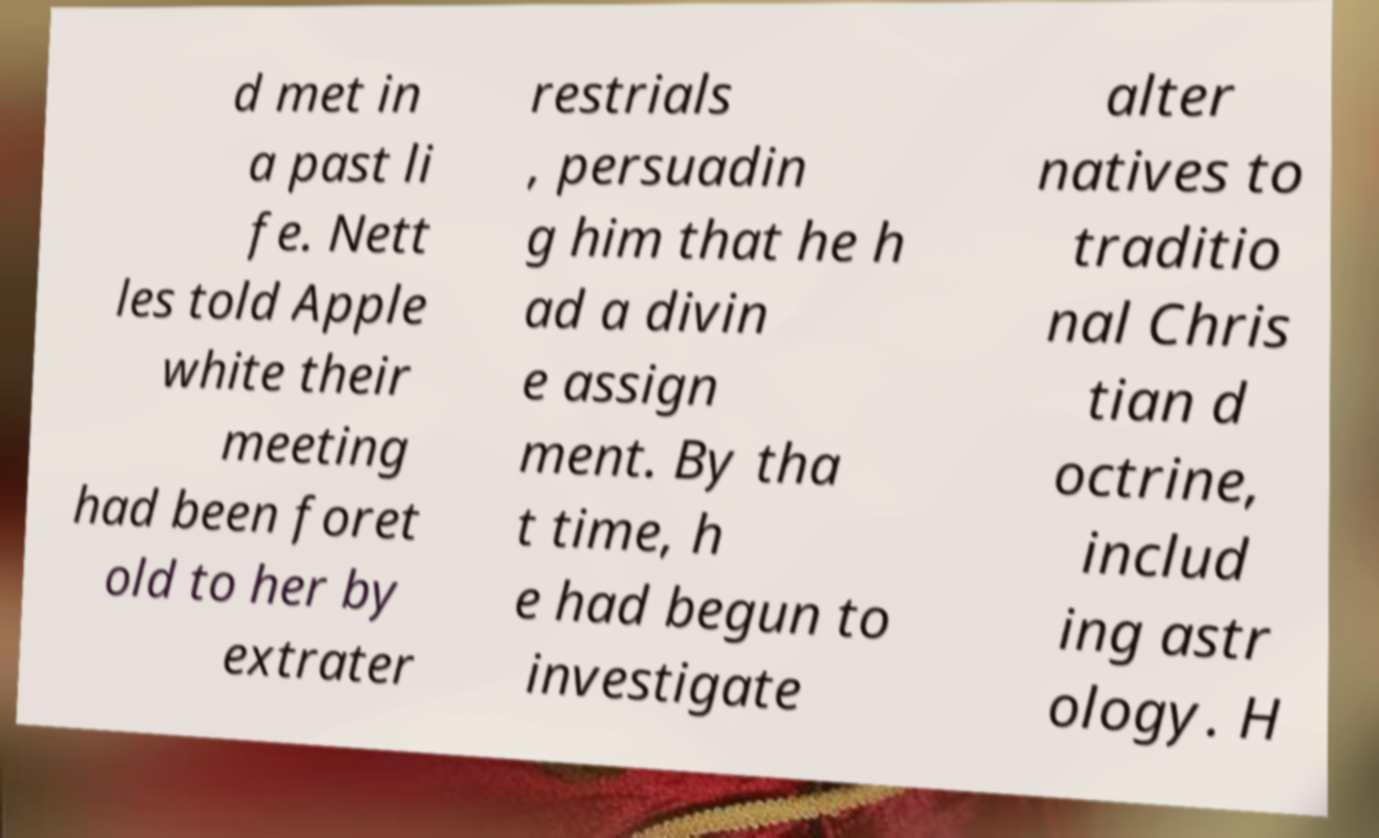For documentation purposes, I need the text within this image transcribed. Could you provide that? d met in a past li fe. Nett les told Apple white their meeting had been foret old to her by extrater restrials , persuadin g him that he h ad a divin e assign ment. By tha t time, h e had begun to investigate alter natives to traditio nal Chris tian d octrine, includ ing astr ology. H 